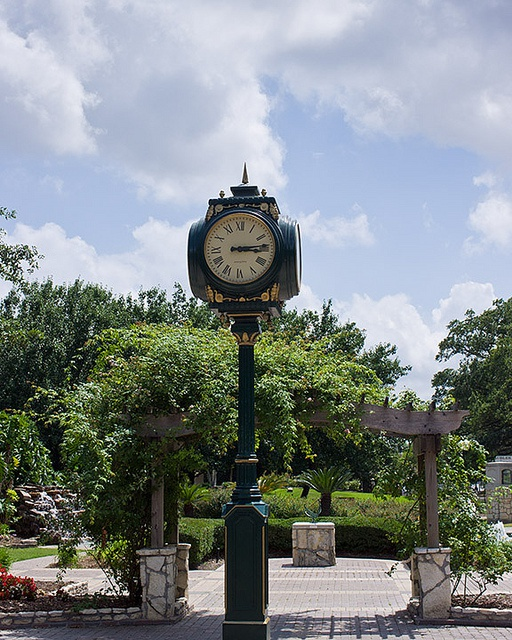Describe the objects in this image and their specific colors. I can see potted plant in lavender, black, darkgreen, lightgray, and gray tones, clock in lavender, gray, and black tones, potted plant in lavender, gray, black, and darkgray tones, and potted plant in lavender, black, maroon, olive, and brown tones in this image. 